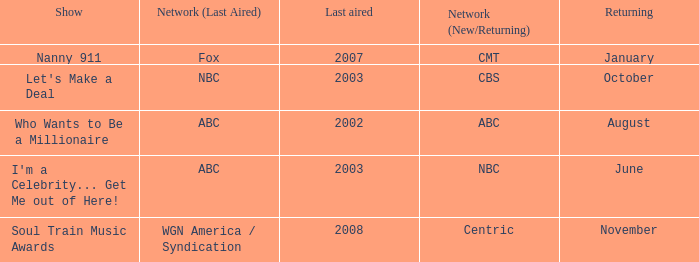Would you mind parsing the complete table? {'header': ['Show', 'Network (Last Aired)', 'Last aired', 'Network (New/Returning)', 'Returning'], 'rows': [['Nanny 911', 'Fox', '2007', 'CMT', 'January'], ["Let's Make a Deal", 'NBC', '2003', 'CBS', 'October'], ['Who Wants to Be a Millionaire', 'ABC', '2002', 'ABC', 'August'], ["I'm a Celebrity... Get Me out of Here!", 'ABC', '2003', 'NBC', 'June'], ['Soul Train Music Awards', 'WGN America / Syndication', '2008', 'Centric', 'November']]} What show was played on ABC laster after 2002? I'm a Celebrity... Get Me out of Here!. 